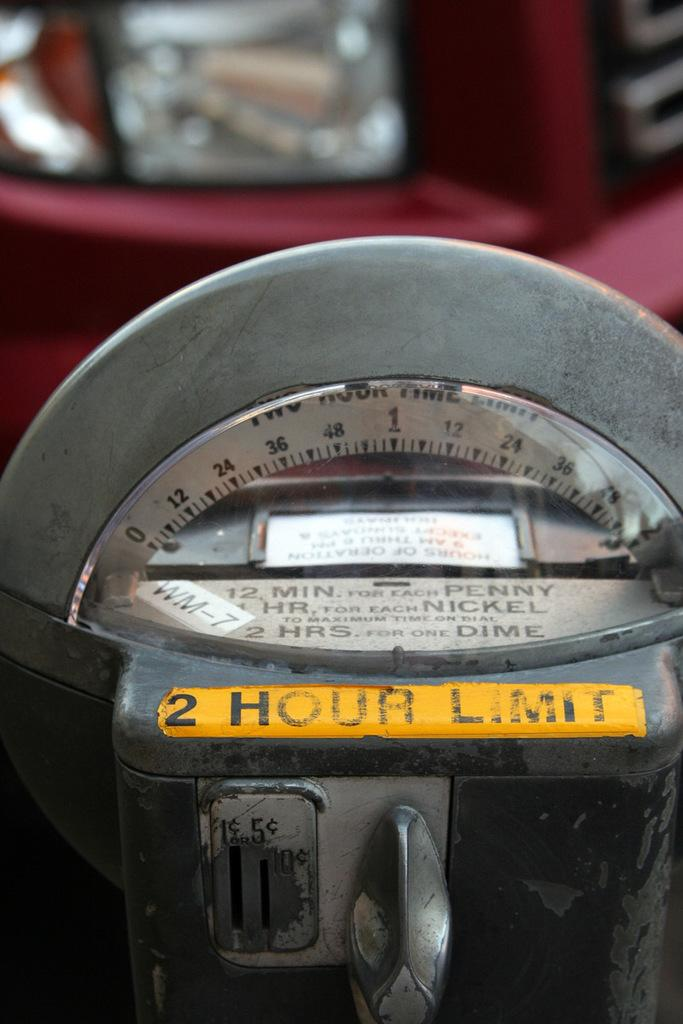<image>
Share a concise interpretation of the image provided. A close up of a parking meter that says 2 hour limit on it. 